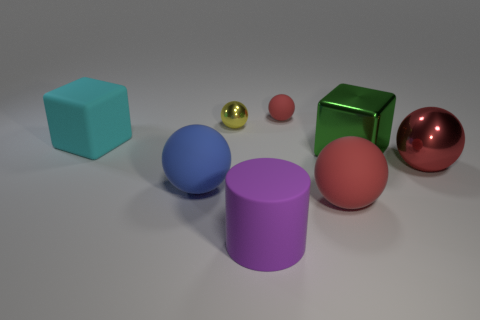What color is the rubber cylinder that is the same size as the green thing? purple 